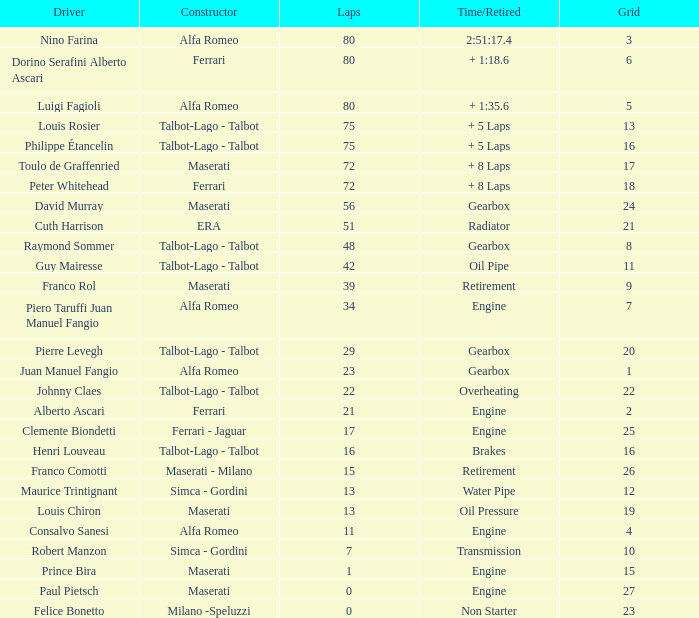When the driver is Juan Manuel Fangio and laps is less than 39, what is the highest grid? 1.0. Would you be able to parse every entry in this table? {'header': ['Driver', 'Constructor', 'Laps', 'Time/Retired', 'Grid'], 'rows': [['Nino Farina', 'Alfa Romeo', '80', '2:51:17.4', '3'], ['Dorino Serafini Alberto Ascari', 'Ferrari', '80', '+ 1:18.6', '6'], ['Luigi Fagioli', 'Alfa Romeo', '80', '+ 1:35.6', '5'], ['Louis Rosier', 'Talbot-Lago - Talbot', '75', '+ 5 Laps', '13'], ['Philippe Étancelin', 'Talbot-Lago - Talbot', '75', '+ 5 Laps', '16'], ['Toulo de Graffenried', 'Maserati', '72', '+ 8 Laps', '17'], ['Peter Whitehead', 'Ferrari', '72', '+ 8 Laps', '18'], ['David Murray', 'Maserati', '56', 'Gearbox', '24'], ['Cuth Harrison', 'ERA', '51', 'Radiator', '21'], ['Raymond Sommer', 'Talbot-Lago - Talbot', '48', 'Gearbox', '8'], ['Guy Mairesse', 'Talbot-Lago - Talbot', '42', 'Oil Pipe', '11'], ['Franco Rol', 'Maserati', '39', 'Retirement', '9'], ['Piero Taruffi Juan Manuel Fangio', 'Alfa Romeo', '34', 'Engine', '7'], ['Pierre Levegh', 'Talbot-Lago - Talbot', '29', 'Gearbox', '20'], ['Juan Manuel Fangio', 'Alfa Romeo', '23', 'Gearbox', '1'], ['Johnny Claes', 'Talbot-Lago - Talbot', '22', 'Overheating', '22'], ['Alberto Ascari', 'Ferrari', '21', 'Engine', '2'], ['Clemente Biondetti', 'Ferrari - Jaguar', '17', 'Engine', '25'], ['Henri Louveau', 'Talbot-Lago - Talbot', '16', 'Brakes', '16'], ['Franco Comotti', 'Maserati - Milano', '15', 'Retirement', '26'], ['Maurice Trintignant', 'Simca - Gordini', '13', 'Water Pipe', '12'], ['Louis Chiron', 'Maserati', '13', 'Oil Pressure', '19'], ['Consalvo Sanesi', 'Alfa Romeo', '11', 'Engine', '4'], ['Robert Manzon', 'Simca - Gordini', '7', 'Transmission', '10'], ['Prince Bira', 'Maserati', '1', 'Engine', '15'], ['Paul Pietsch', 'Maserati', '0', 'Engine', '27'], ['Felice Bonetto', 'Milano -Speluzzi', '0', 'Non Starter', '23']]} 